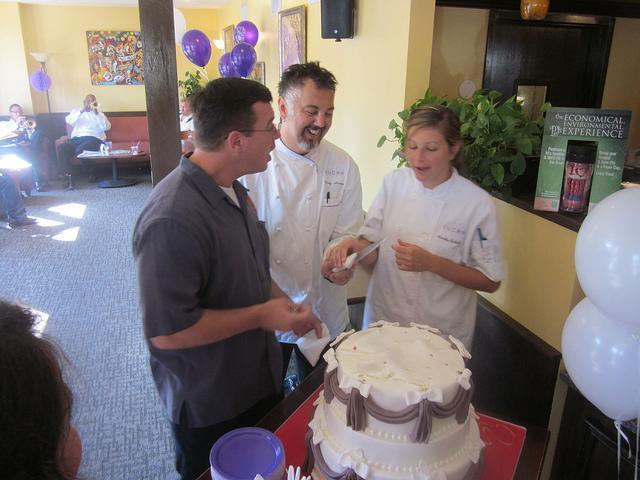How many people can be seen?
Give a very brief answer. 5. 